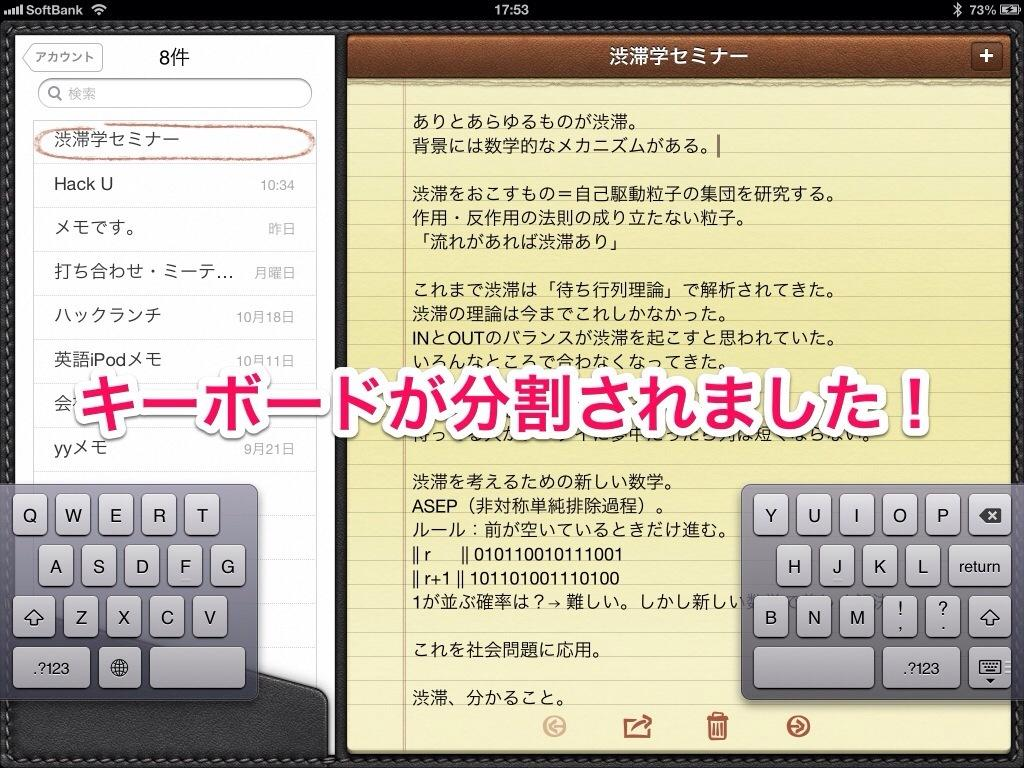<image>
Present a compact description of the photo's key features. A monitor shows writing in an asian language and shows that the time is 17:53. 